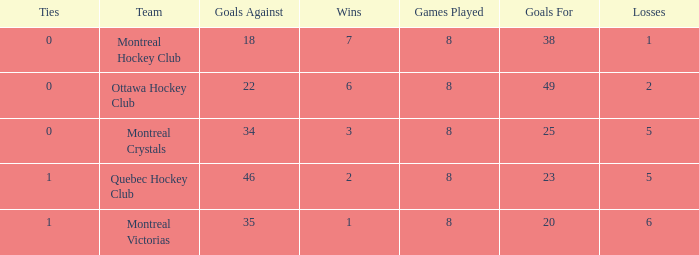What is the average losses when the wins is 3? 5.0. 